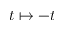Convert formula to latex. <formula><loc_0><loc_0><loc_500><loc_500>t \mapsto - t</formula> 